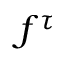Convert formula to latex. <formula><loc_0><loc_0><loc_500><loc_500>f ^ { \tau }</formula> 